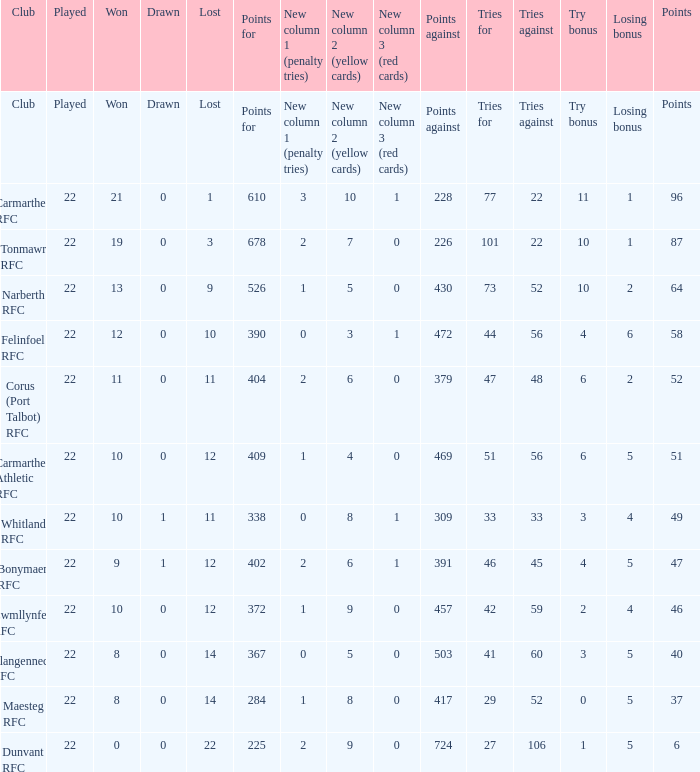Name the losing bonus of 96 points 1.0. 